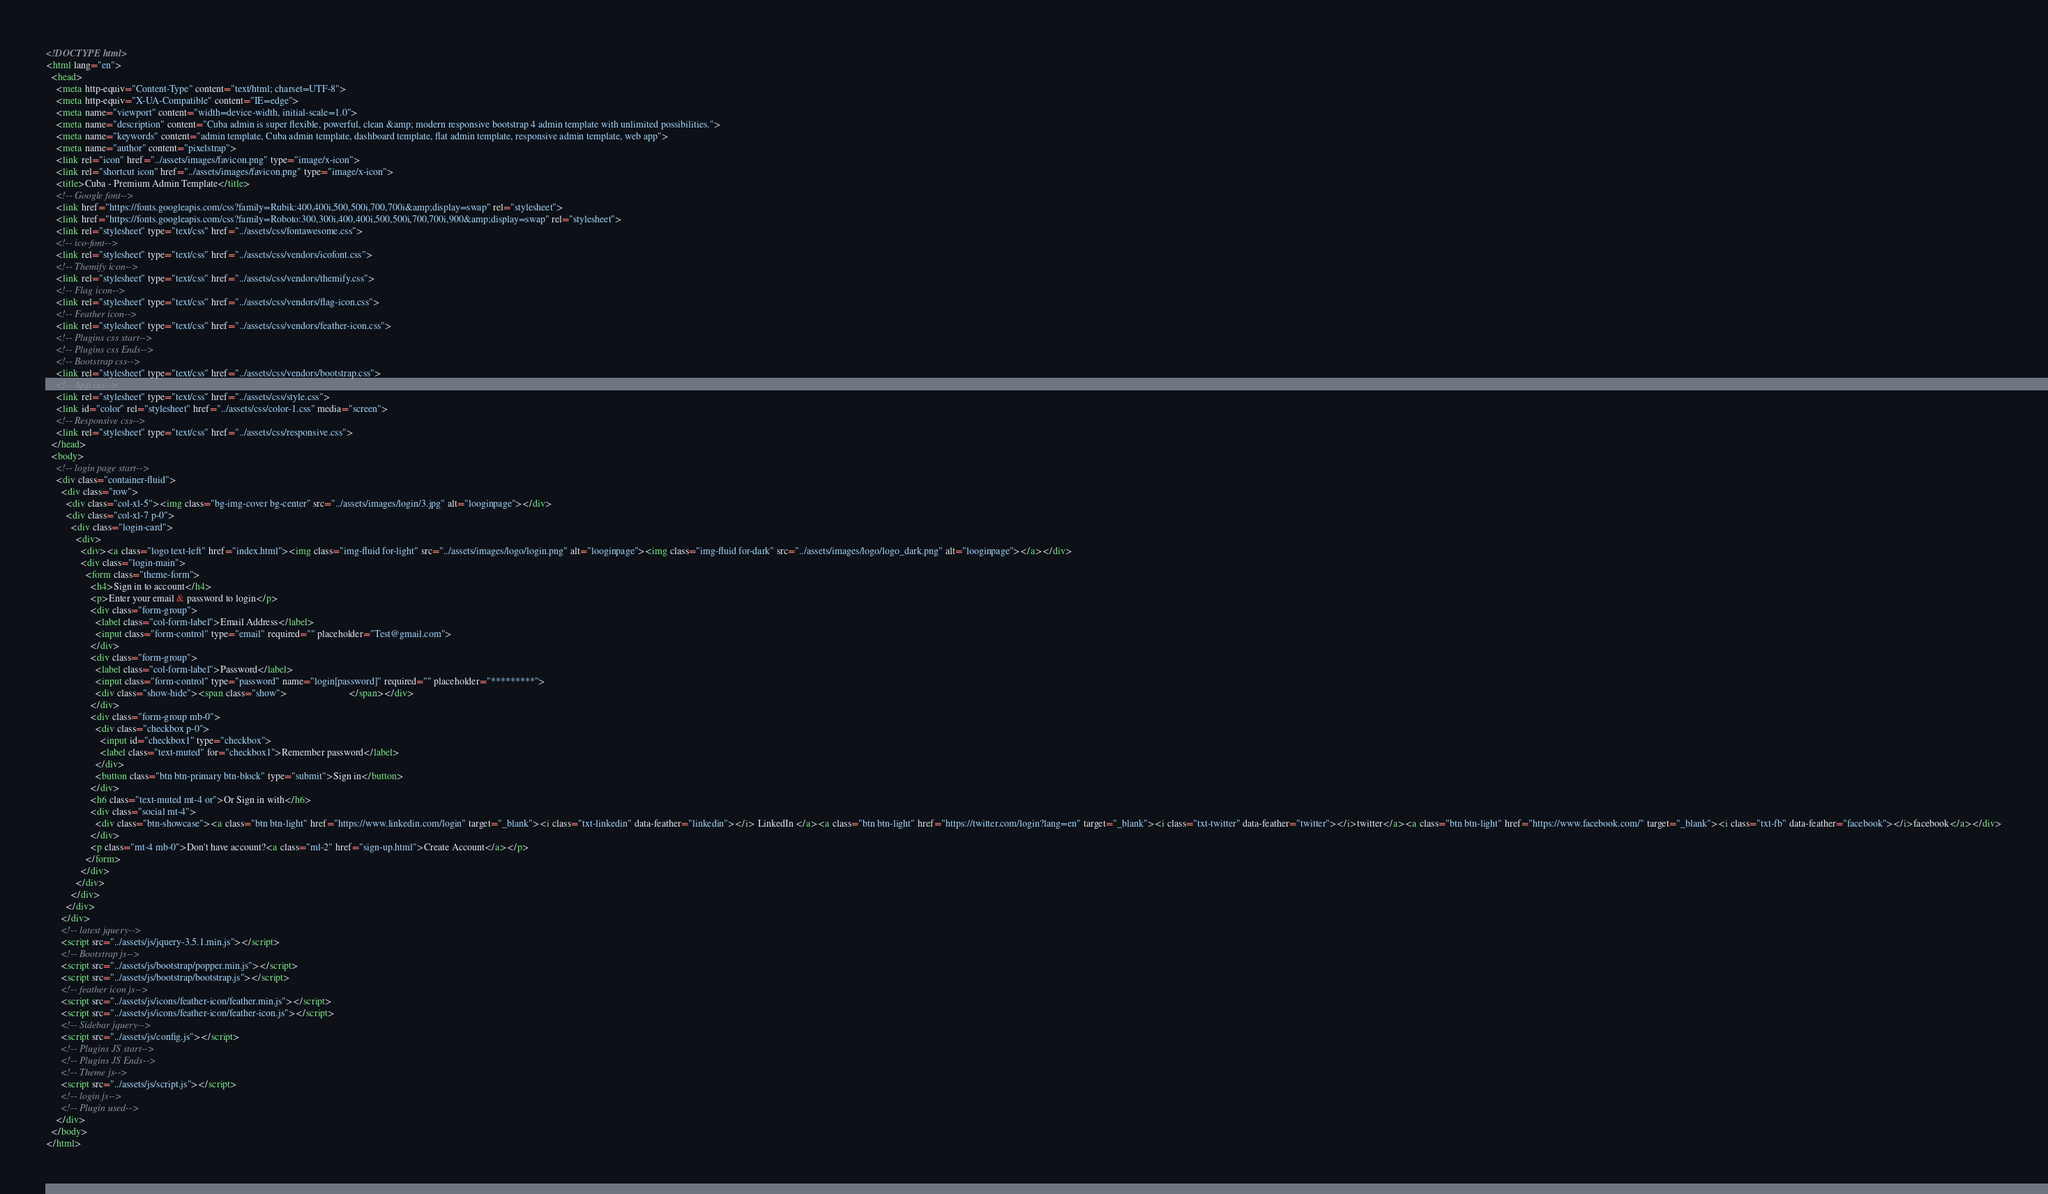<code> <loc_0><loc_0><loc_500><loc_500><_HTML_><!DOCTYPE html>
<html lang="en">
  <head>
    <meta http-equiv="Content-Type" content="text/html; charset=UTF-8">
    <meta http-equiv="X-UA-Compatible" content="IE=edge">
    <meta name="viewport" content="width=device-width, initial-scale=1.0">
    <meta name="description" content="Cuba admin is super flexible, powerful, clean &amp; modern responsive bootstrap 4 admin template with unlimited possibilities.">
    <meta name="keywords" content="admin template, Cuba admin template, dashboard template, flat admin template, responsive admin template, web app">
    <meta name="author" content="pixelstrap">
    <link rel="icon" href="../assets/images/favicon.png" type="image/x-icon">
    <link rel="shortcut icon" href="../assets/images/favicon.png" type="image/x-icon">
    <title>Cuba - Premium Admin Template</title>
    <!-- Google font-->
    <link href="https://fonts.googleapis.com/css?family=Rubik:400,400i,500,500i,700,700i&amp;display=swap" rel="stylesheet">
    <link href="https://fonts.googleapis.com/css?family=Roboto:300,300i,400,400i,500,500i,700,700i,900&amp;display=swap" rel="stylesheet">
    <link rel="stylesheet" type="text/css" href="../assets/css/fontawesome.css">
    <!-- ico-font-->
    <link rel="stylesheet" type="text/css" href="../assets/css/vendors/icofont.css">
    <!-- Themify icon-->
    <link rel="stylesheet" type="text/css" href="../assets/css/vendors/themify.css">
    <!-- Flag icon-->
    <link rel="stylesheet" type="text/css" href="../assets/css/vendors/flag-icon.css">
    <!-- Feather icon-->
    <link rel="stylesheet" type="text/css" href="../assets/css/vendors/feather-icon.css">
    <!-- Plugins css start-->
    <!-- Plugins css Ends-->
    <!-- Bootstrap css-->
    <link rel="stylesheet" type="text/css" href="../assets/css/vendors/bootstrap.css">
    <!-- App css-->
    <link rel="stylesheet" type="text/css" href="../assets/css/style.css">
    <link id="color" rel="stylesheet" href="../assets/css/color-1.css" media="screen">
    <!-- Responsive css-->
    <link rel="stylesheet" type="text/css" href="../assets/css/responsive.css">
  </head>
  <body>
    <!-- login page start-->
    <div class="container-fluid">
      <div class="row">
        <div class="col-xl-5"><img class="bg-img-cover bg-center" src="../assets/images/login/3.jpg" alt="looginpage"></div>
        <div class="col-xl-7 p-0">    
          <div class="login-card">
            <div>
              <div><a class="logo text-left" href="index.html"><img class="img-fluid for-light" src="../assets/images/logo/login.png" alt="looginpage"><img class="img-fluid for-dark" src="../assets/images/logo/logo_dark.png" alt="looginpage"></a></div>
              <div class="login-main"> 
                <form class="theme-form">
                  <h4>Sign in to account</h4>
                  <p>Enter your email & password to login</p>
                  <div class="form-group">
                    <label class="col-form-label">Email Address</label>
                    <input class="form-control" type="email" required="" placeholder="Test@gmail.com">
                  </div>
                  <div class="form-group">
                    <label class="col-form-label">Password</label>
                    <input class="form-control" type="password" name="login[password]" required="" placeholder="*********">
                    <div class="show-hide"><span class="show">                         </span></div>
                  </div>
                  <div class="form-group mb-0">
                    <div class="checkbox p-0">
                      <input id="checkbox1" type="checkbox">
                      <label class="text-muted" for="checkbox1">Remember password</label>
                    </div>
                    <button class="btn btn-primary btn-block" type="submit">Sign in</button>
                  </div>
                  <h6 class="text-muted mt-4 or">Or Sign in with</h6>
                  <div class="social mt-4">
                    <div class="btn-showcase"><a class="btn btn-light" href="https://www.linkedin.com/login" target="_blank"><i class="txt-linkedin" data-feather="linkedin"></i> LinkedIn </a><a class="btn btn-light" href="https://twitter.com/login?lang=en" target="_blank"><i class="txt-twitter" data-feather="twitter"></i>twitter</a><a class="btn btn-light" href="https://www.facebook.com/" target="_blank"><i class="txt-fb" data-feather="facebook"></i>facebook</a></div>
                  </div>
                  <p class="mt-4 mb-0">Don't have account?<a class="ml-2" href="sign-up.html">Create Account</a></p>
                </form>
              </div>
            </div>
          </div>
        </div>
      </div>
      <!-- latest jquery-->
      <script src="../assets/js/jquery-3.5.1.min.js"></script>
      <!-- Bootstrap js-->
      <script src="../assets/js/bootstrap/popper.min.js"></script>
      <script src="../assets/js/bootstrap/bootstrap.js"></script>
      <!-- feather icon js-->
      <script src="../assets/js/icons/feather-icon/feather.min.js"></script>
      <script src="../assets/js/icons/feather-icon/feather-icon.js"></script>
      <!-- Sidebar jquery-->
      <script src="../assets/js/config.js"></script>
      <!-- Plugins JS start-->
      <!-- Plugins JS Ends-->
      <!-- Theme js-->
      <script src="../assets/js/script.js"></script>
      <!-- login js-->
      <!-- Plugin used-->
    </div>
  </body>
</html></code> 